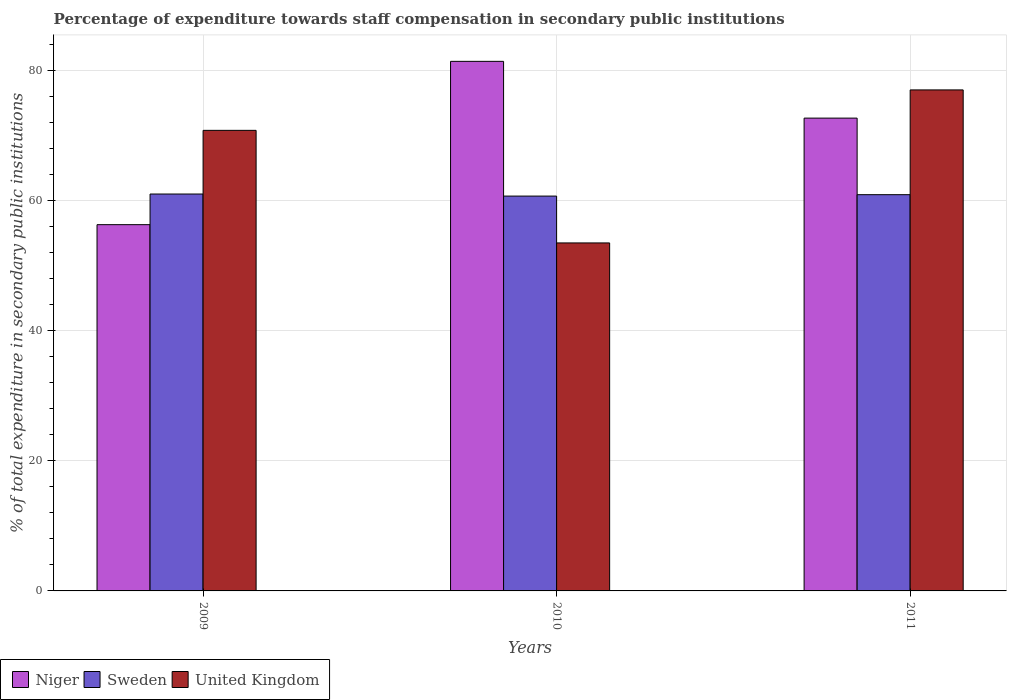Are the number of bars per tick equal to the number of legend labels?
Offer a very short reply. Yes. Are the number of bars on each tick of the X-axis equal?
Ensure brevity in your answer.  Yes. How many bars are there on the 3rd tick from the left?
Your answer should be compact. 3. How many bars are there on the 2nd tick from the right?
Your answer should be very brief. 3. What is the percentage of expenditure towards staff compensation in United Kingdom in 2011?
Provide a short and direct response. 76.96. Across all years, what is the maximum percentage of expenditure towards staff compensation in Niger?
Your response must be concise. 81.35. Across all years, what is the minimum percentage of expenditure towards staff compensation in Sweden?
Keep it short and to the point. 60.65. In which year was the percentage of expenditure towards staff compensation in United Kingdom maximum?
Your answer should be very brief. 2011. What is the total percentage of expenditure towards staff compensation in United Kingdom in the graph?
Offer a terse response. 201.17. What is the difference between the percentage of expenditure towards staff compensation in Sweden in 2009 and that in 2010?
Provide a short and direct response. 0.32. What is the difference between the percentage of expenditure towards staff compensation in Sweden in 2010 and the percentage of expenditure towards staff compensation in United Kingdom in 2009?
Give a very brief answer. -10.1. What is the average percentage of expenditure towards staff compensation in United Kingdom per year?
Ensure brevity in your answer.  67.06. In the year 2009, what is the difference between the percentage of expenditure towards staff compensation in Sweden and percentage of expenditure towards staff compensation in United Kingdom?
Keep it short and to the point. -9.78. What is the ratio of the percentage of expenditure towards staff compensation in Sweden in 2009 to that in 2011?
Keep it short and to the point. 1. What is the difference between the highest and the second highest percentage of expenditure towards staff compensation in Sweden?
Keep it short and to the point. 0.1. What is the difference between the highest and the lowest percentage of expenditure towards staff compensation in Niger?
Offer a very short reply. 25.09. In how many years, is the percentage of expenditure towards staff compensation in Sweden greater than the average percentage of expenditure towards staff compensation in Sweden taken over all years?
Your answer should be compact. 2. What does the 2nd bar from the left in 2011 represents?
Ensure brevity in your answer.  Sweden. What does the 3rd bar from the right in 2011 represents?
Offer a terse response. Niger. Are all the bars in the graph horizontal?
Ensure brevity in your answer.  No. What is the difference between two consecutive major ticks on the Y-axis?
Provide a succinct answer. 20. How are the legend labels stacked?
Your answer should be very brief. Horizontal. What is the title of the graph?
Provide a succinct answer. Percentage of expenditure towards staff compensation in secondary public institutions. What is the label or title of the Y-axis?
Offer a very short reply. % of total expenditure in secondary public institutions. What is the % of total expenditure in secondary public institutions in Niger in 2009?
Your answer should be compact. 56.26. What is the % of total expenditure in secondary public institutions in Sweden in 2009?
Offer a very short reply. 60.97. What is the % of total expenditure in secondary public institutions in United Kingdom in 2009?
Your response must be concise. 70.75. What is the % of total expenditure in secondary public institutions in Niger in 2010?
Offer a terse response. 81.35. What is the % of total expenditure in secondary public institutions in Sweden in 2010?
Your response must be concise. 60.65. What is the % of total expenditure in secondary public institutions of United Kingdom in 2010?
Offer a terse response. 53.46. What is the % of total expenditure in secondary public institutions in Niger in 2011?
Provide a short and direct response. 72.63. What is the % of total expenditure in secondary public institutions in Sweden in 2011?
Provide a succinct answer. 60.87. What is the % of total expenditure in secondary public institutions in United Kingdom in 2011?
Your answer should be very brief. 76.96. Across all years, what is the maximum % of total expenditure in secondary public institutions of Niger?
Ensure brevity in your answer.  81.35. Across all years, what is the maximum % of total expenditure in secondary public institutions of Sweden?
Keep it short and to the point. 60.97. Across all years, what is the maximum % of total expenditure in secondary public institutions in United Kingdom?
Give a very brief answer. 76.96. Across all years, what is the minimum % of total expenditure in secondary public institutions of Niger?
Make the answer very short. 56.26. Across all years, what is the minimum % of total expenditure in secondary public institutions in Sweden?
Provide a succinct answer. 60.65. Across all years, what is the minimum % of total expenditure in secondary public institutions of United Kingdom?
Give a very brief answer. 53.46. What is the total % of total expenditure in secondary public institutions in Niger in the graph?
Offer a very short reply. 210.24. What is the total % of total expenditure in secondary public institutions in Sweden in the graph?
Your answer should be compact. 182.49. What is the total % of total expenditure in secondary public institutions of United Kingdom in the graph?
Keep it short and to the point. 201.17. What is the difference between the % of total expenditure in secondary public institutions in Niger in 2009 and that in 2010?
Give a very brief answer. -25.09. What is the difference between the % of total expenditure in secondary public institutions of Sweden in 2009 and that in 2010?
Offer a very short reply. 0.32. What is the difference between the % of total expenditure in secondary public institutions in United Kingdom in 2009 and that in 2010?
Your answer should be compact. 17.29. What is the difference between the % of total expenditure in secondary public institutions of Niger in 2009 and that in 2011?
Your response must be concise. -16.37. What is the difference between the % of total expenditure in secondary public institutions of Sweden in 2009 and that in 2011?
Offer a very short reply. 0.1. What is the difference between the % of total expenditure in secondary public institutions of United Kingdom in 2009 and that in 2011?
Keep it short and to the point. -6.21. What is the difference between the % of total expenditure in secondary public institutions of Niger in 2010 and that in 2011?
Offer a terse response. 8.72. What is the difference between the % of total expenditure in secondary public institutions of Sweden in 2010 and that in 2011?
Offer a terse response. -0.21. What is the difference between the % of total expenditure in secondary public institutions in United Kingdom in 2010 and that in 2011?
Your answer should be very brief. -23.5. What is the difference between the % of total expenditure in secondary public institutions of Niger in 2009 and the % of total expenditure in secondary public institutions of Sweden in 2010?
Give a very brief answer. -4.39. What is the difference between the % of total expenditure in secondary public institutions in Niger in 2009 and the % of total expenditure in secondary public institutions in United Kingdom in 2010?
Ensure brevity in your answer.  2.8. What is the difference between the % of total expenditure in secondary public institutions in Sweden in 2009 and the % of total expenditure in secondary public institutions in United Kingdom in 2010?
Give a very brief answer. 7.51. What is the difference between the % of total expenditure in secondary public institutions in Niger in 2009 and the % of total expenditure in secondary public institutions in Sweden in 2011?
Give a very brief answer. -4.61. What is the difference between the % of total expenditure in secondary public institutions in Niger in 2009 and the % of total expenditure in secondary public institutions in United Kingdom in 2011?
Your answer should be compact. -20.7. What is the difference between the % of total expenditure in secondary public institutions in Sweden in 2009 and the % of total expenditure in secondary public institutions in United Kingdom in 2011?
Provide a short and direct response. -15.99. What is the difference between the % of total expenditure in secondary public institutions in Niger in 2010 and the % of total expenditure in secondary public institutions in Sweden in 2011?
Your answer should be compact. 20.48. What is the difference between the % of total expenditure in secondary public institutions of Niger in 2010 and the % of total expenditure in secondary public institutions of United Kingdom in 2011?
Your answer should be very brief. 4.39. What is the difference between the % of total expenditure in secondary public institutions of Sweden in 2010 and the % of total expenditure in secondary public institutions of United Kingdom in 2011?
Offer a very short reply. -16.31. What is the average % of total expenditure in secondary public institutions in Niger per year?
Make the answer very short. 70.08. What is the average % of total expenditure in secondary public institutions in Sweden per year?
Offer a very short reply. 60.83. What is the average % of total expenditure in secondary public institutions of United Kingdom per year?
Make the answer very short. 67.06. In the year 2009, what is the difference between the % of total expenditure in secondary public institutions of Niger and % of total expenditure in secondary public institutions of Sweden?
Provide a succinct answer. -4.71. In the year 2009, what is the difference between the % of total expenditure in secondary public institutions of Niger and % of total expenditure in secondary public institutions of United Kingdom?
Provide a short and direct response. -14.49. In the year 2009, what is the difference between the % of total expenditure in secondary public institutions of Sweden and % of total expenditure in secondary public institutions of United Kingdom?
Provide a succinct answer. -9.78. In the year 2010, what is the difference between the % of total expenditure in secondary public institutions in Niger and % of total expenditure in secondary public institutions in Sweden?
Your answer should be compact. 20.7. In the year 2010, what is the difference between the % of total expenditure in secondary public institutions in Niger and % of total expenditure in secondary public institutions in United Kingdom?
Provide a succinct answer. 27.89. In the year 2010, what is the difference between the % of total expenditure in secondary public institutions in Sweden and % of total expenditure in secondary public institutions in United Kingdom?
Your response must be concise. 7.2. In the year 2011, what is the difference between the % of total expenditure in secondary public institutions in Niger and % of total expenditure in secondary public institutions in Sweden?
Your answer should be very brief. 11.76. In the year 2011, what is the difference between the % of total expenditure in secondary public institutions in Niger and % of total expenditure in secondary public institutions in United Kingdom?
Make the answer very short. -4.33. In the year 2011, what is the difference between the % of total expenditure in secondary public institutions in Sweden and % of total expenditure in secondary public institutions in United Kingdom?
Make the answer very short. -16.09. What is the ratio of the % of total expenditure in secondary public institutions of Niger in 2009 to that in 2010?
Ensure brevity in your answer.  0.69. What is the ratio of the % of total expenditure in secondary public institutions of Sweden in 2009 to that in 2010?
Your answer should be very brief. 1.01. What is the ratio of the % of total expenditure in secondary public institutions in United Kingdom in 2009 to that in 2010?
Keep it short and to the point. 1.32. What is the ratio of the % of total expenditure in secondary public institutions of Niger in 2009 to that in 2011?
Your response must be concise. 0.77. What is the ratio of the % of total expenditure in secondary public institutions of Sweden in 2009 to that in 2011?
Your answer should be compact. 1. What is the ratio of the % of total expenditure in secondary public institutions in United Kingdom in 2009 to that in 2011?
Offer a very short reply. 0.92. What is the ratio of the % of total expenditure in secondary public institutions of Niger in 2010 to that in 2011?
Provide a short and direct response. 1.12. What is the ratio of the % of total expenditure in secondary public institutions in United Kingdom in 2010 to that in 2011?
Provide a short and direct response. 0.69. What is the difference between the highest and the second highest % of total expenditure in secondary public institutions of Niger?
Your answer should be very brief. 8.72. What is the difference between the highest and the second highest % of total expenditure in secondary public institutions of Sweden?
Give a very brief answer. 0.1. What is the difference between the highest and the second highest % of total expenditure in secondary public institutions in United Kingdom?
Your answer should be very brief. 6.21. What is the difference between the highest and the lowest % of total expenditure in secondary public institutions in Niger?
Offer a very short reply. 25.09. What is the difference between the highest and the lowest % of total expenditure in secondary public institutions of Sweden?
Offer a very short reply. 0.32. What is the difference between the highest and the lowest % of total expenditure in secondary public institutions of United Kingdom?
Provide a short and direct response. 23.5. 